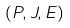<formula> <loc_0><loc_0><loc_500><loc_500>( P , J , E )</formula> 